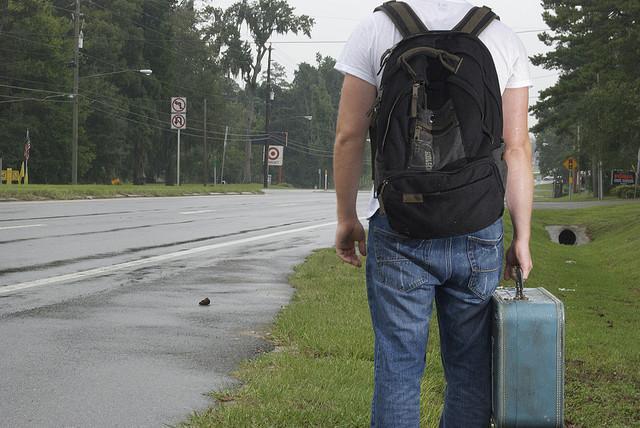What sign is on right side of the road?
Choose the correct response and explain in the format: 'Answer: answer
Rationale: rationale.'
Options: Signal, slow, slow, stop. Answer: signal.
Rationale: There is a traffic signal up ahead. 